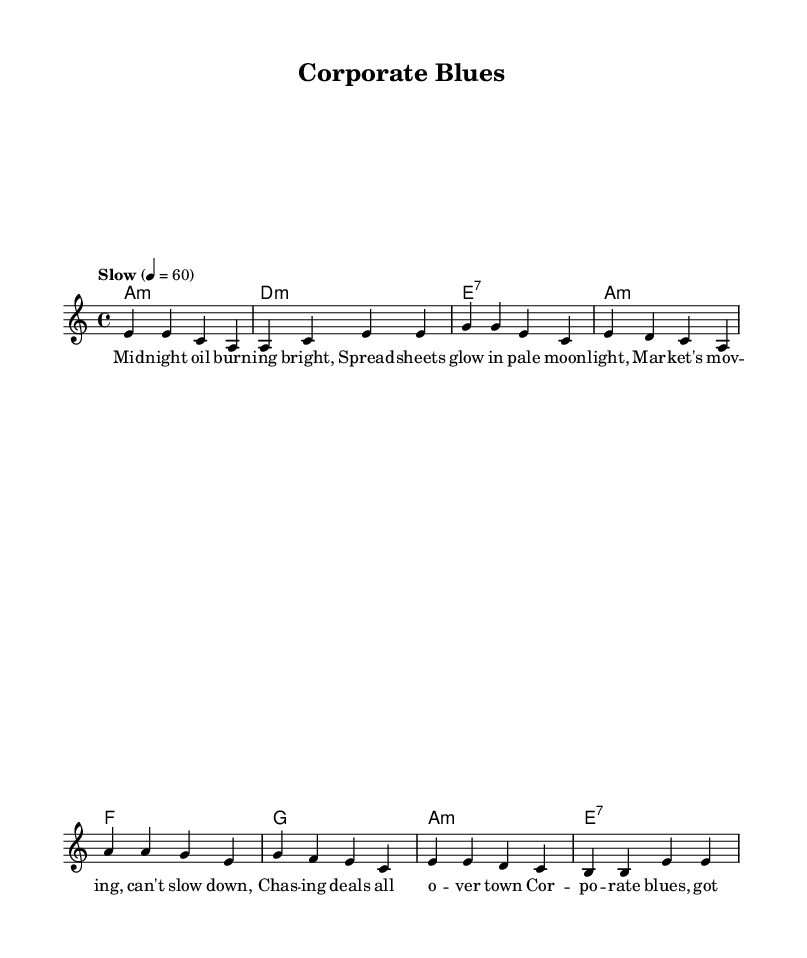What is the key signature of this music? The key signature is indicated by the number of sharps or flats at the beginning of the staff. In this case, the absence of sharps or flats reveals that the music is in A minor.
Answer: A minor What is the time signature of this piece? The time signature is given at the beginning of the music. Here, it is displayed as 4/4, meaning there are four beats in a measure and a quarter note gets one beat.
Answer: 4/4 What is the tempo indication for this piece? The tempo is usually found at the beginning of the score and expressed in beats per minute or descriptive words. This score indicates "Slow" at a rate of 60 beats per minute.
Answer: Slow How many measures are there in the verse section? To determine the number of measures in the verse section, count each vertical line separating the notes in that section. There are four measures in the verse.
Answer: Four What distinctive musical structure is commonly found in Blues music? Blues typically employs a call-and-response format, often using a 12-bar structure. In this score, one can observe the recurring verse and chorus pattern, indicative of a blues structure.
Answer: Call-and-response What is the lyrical theme captured in the chorus? Analyzing the lyrics reveals a focus on themes of loneliness and the struggles inherent in high-stakes business environments. The chorus emphasizes feeling burdened by corporate pressures.
Answer: Loneliness and corporate struggle What chord follows the first measure of the chorus? The chord progression is shown in the chord names section. After the first measure of the chorus, which is marked "F1," the next chord is "G."
Answer: G 